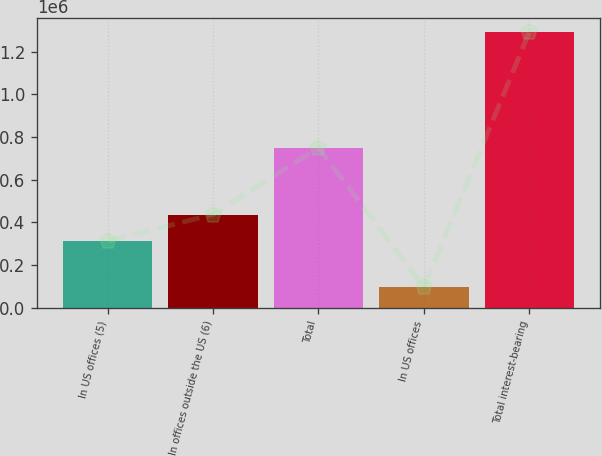Convert chart. <chart><loc_0><loc_0><loc_500><loc_500><bar_chart><fcel>In US offices (5)<fcel>In offices outside the US (6)<fcel>Total<fcel>In US offices<fcel>Total interest-bearing<nl><fcel>313094<fcel>436949<fcel>750043<fcel>96258<fcel>1.29264e+06<nl></chart> 